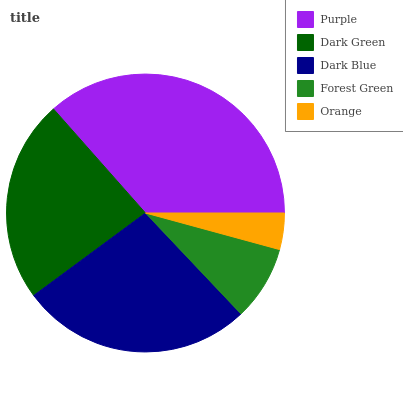Is Orange the minimum?
Answer yes or no. Yes. Is Purple the maximum?
Answer yes or no. Yes. Is Dark Green the minimum?
Answer yes or no. No. Is Dark Green the maximum?
Answer yes or no. No. Is Purple greater than Dark Green?
Answer yes or no. Yes. Is Dark Green less than Purple?
Answer yes or no. Yes. Is Dark Green greater than Purple?
Answer yes or no. No. Is Purple less than Dark Green?
Answer yes or no. No. Is Dark Green the high median?
Answer yes or no. Yes. Is Dark Green the low median?
Answer yes or no. Yes. Is Dark Blue the high median?
Answer yes or no. No. Is Dark Blue the low median?
Answer yes or no. No. 